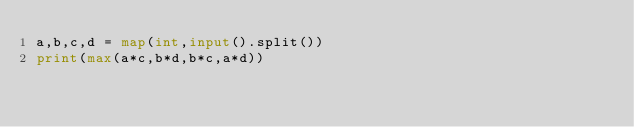<code> <loc_0><loc_0><loc_500><loc_500><_Python_>a,b,c,d = map(int,input().split())
print(max(a*c,b*d,b*c,a*d))</code> 